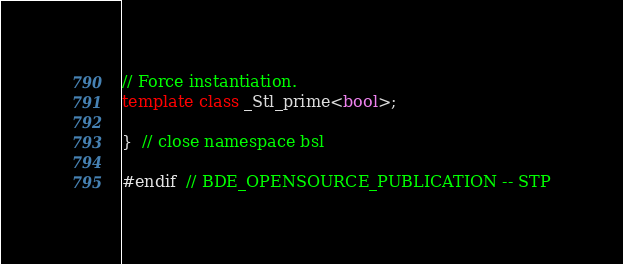<code> <loc_0><loc_0><loc_500><loc_500><_C++_>
// Force instantiation.
template class _Stl_prime<bool>;

}  // close namespace bsl

#endif  // BDE_OPENSOURCE_PUBLICATION -- STP
</code> 